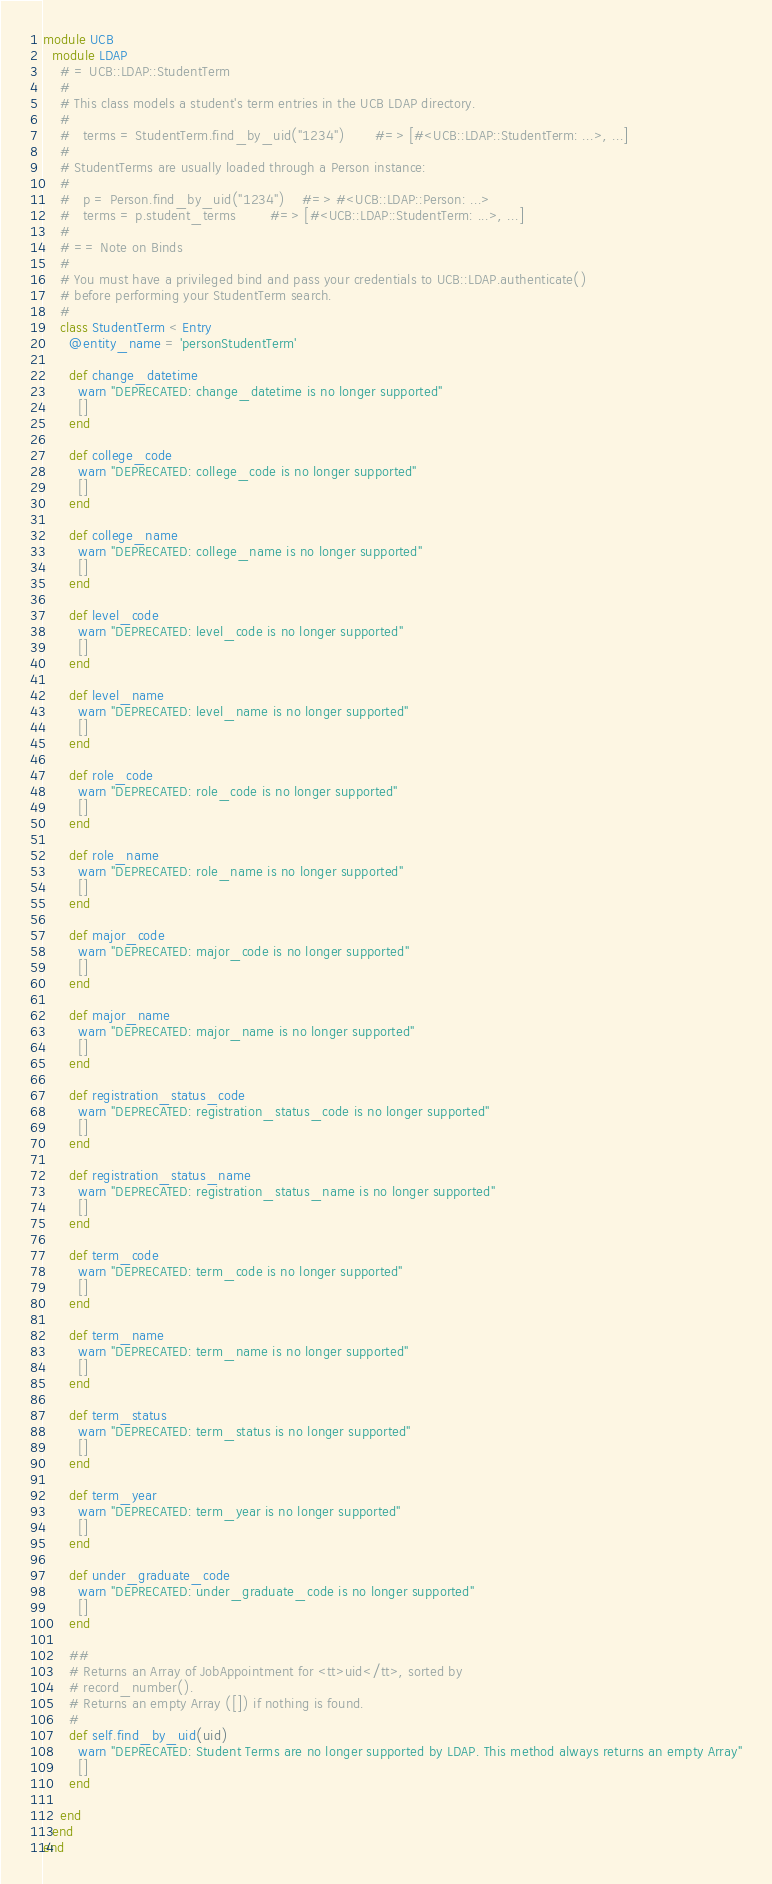<code> <loc_0><loc_0><loc_500><loc_500><_Ruby_>module UCB
  module LDAP
    # = UCB::LDAP::StudentTerm
    #
    # This class models a student's term entries in the UCB LDAP directory.
    #
    #   terms = StudentTerm.find_by_uid("1234")       #=> [#<UCB::LDAP::StudentTerm: ...>, ...]
    #
    # StudentTerms are usually loaded through a Person instance:
    #
    #   p = Person.find_by_uid("1234")    #=> #<UCB::LDAP::Person: ...>
    #   terms = p.student_terms        #=> [#<UCB::LDAP::StudentTerm: ...>, ...]
    #
    # == Note on Binds
    #
    # You must have a privileged bind and pass your credentials to UCB::LDAP.authenticate()
    # before performing your StudentTerm search.
    #
    class StudentTerm < Entry
      @entity_name = 'personStudentTerm'

      def change_datetime
        warn "DEPRECATED: change_datetime is no longer supported"
        []
      end

      def college_code
        warn "DEPRECATED: college_code is no longer supported"
        []
      end

      def college_name
        warn "DEPRECATED: college_name is no longer supported"
        []
      end

      def level_code
        warn "DEPRECATED: level_code is no longer supported"
        []
      end

      def level_name
        warn "DEPRECATED: level_name is no longer supported"
        []
      end

      def role_code
        warn "DEPRECATED: role_code is no longer supported"
        []
      end

      def role_name
        warn "DEPRECATED: role_name is no longer supported"
        []
      end

      def major_code
        warn "DEPRECATED: major_code is no longer supported"
        []
      end

      def major_name
        warn "DEPRECATED: major_name is no longer supported"
        []
      end

      def registration_status_code
        warn "DEPRECATED: registration_status_code is no longer supported"
        []
      end

      def registration_status_name
        warn "DEPRECATED: registration_status_name is no longer supported"
        []
      end

      def term_code
        warn "DEPRECATED: term_code is no longer supported"
        []
      end

      def term_name
        warn "DEPRECATED: term_name is no longer supported"
        []
      end

      def term_status
        warn "DEPRECATED: term_status is no longer supported"
        []
      end

      def term_year
        warn "DEPRECATED: term_year is no longer supported"
        []
      end

      def under_graduate_code
        warn "DEPRECATED: under_graduate_code is no longer supported"
        []
      end

      ##
      # Returns an Array of JobAppointment for <tt>uid</tt>, sorted by
      # record_number().
      # Returns an empty Array ([]) if nothing is found.
      #
      def self.find_by_uid(uid)
        warn "DEPRECATED: Student Terms are no longer supported by LDAP. This method always returns an empty Array"
        []
      end

    end
  end
end
</code> 